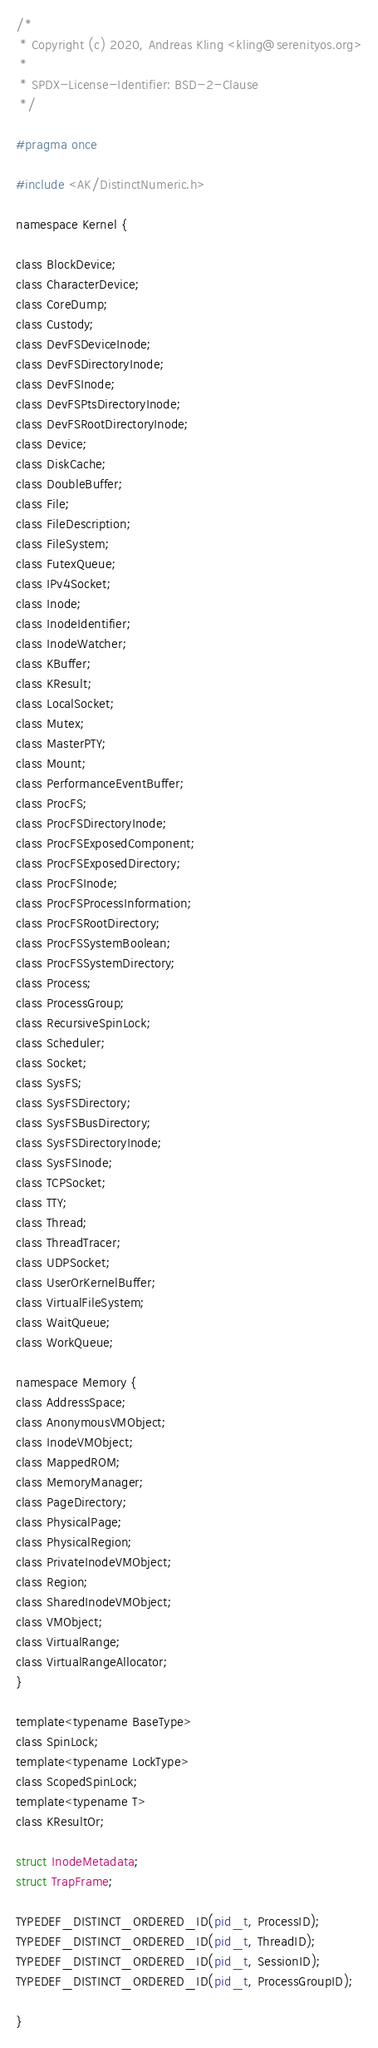Convert code to text. <code><loc_0><loc_0><loc_500><loc_500><_C_>/*
 * Copyright (c) 2020, Andreas Kling <kling@serenityos.org>
 *
 * SPDX-License-Identifier: BSD-2-Clause
 */

#pragma once

#include <AK/DistinctNumeric.h>

namespace Kernel {

class BlockDevice;
class CharacterDevice;
class CoreDump;
class Custody;
class DevFSDeviceInode;
class DevFSDirectoryInode;
class DevFSInode;
class DevFSPtsDirectoryInode;
class DevFSRootDirectoryInode;
class Device;
class DiskCache;
class DoubleBuffer;
class File;
class FileDescription;
class FileSystem;
class FutexQueue;
class IPv4Socket;
class Inode;
class InodeIdentifier;
class InodeWatcher;
class KBuffer;
class KResult;
class LocalSocket;
class Mutex;
class MasterPTY;
class Mount;
class PerformanceEventBuffer;
class ProcFS;
class ProcFSDirectoryInode;
class ProcFSExposedComponent;
class ProcFSExposedDirectory;
class ProcFSInode;
class ProcFSProcessInformation;
class ProcFSRootDirectory;
class ProcFSSystemBoolean;
class ProcFSSystemDirectory;
class Process;
class ProcessGroup;
class RecursiveSpinLock;
class Scheduler;
class Socket;
class SysFS;
class SysFSDirectory;
class SysFSBusDirectory;
class SysFSDirectoryInode;
class SysFSInode;
class TCPSocket;
class TTY;
class Thread;
class ThreadTracer;
class UDPSocket;
class UserOrKernelBuffer;
class VirtualFileSystem;
class WaitQueue;
class WorkQueue;

namespace Memory {
class AddressSpace;
class AnonymousVMObject;
class InodeVMObject;
class MappedROM;
class MemoryManager;
class PageDirectory;
class PhysicalPage;
class PhysicalRegion;
class PrivateInodeVMObject;
class Region;
class SharedInodeVMObject;
class VMObject;
class VirtualRange;
class VirtualRangeAllocator;
}

template<typename BaseType>
class SpinLock;
template<typename LockType>
class ScopedSpinLock;
template<typename T>
class KResultOr;

struct InodeMetadata;
struct TrapFrame;

TYPEDEF_DISTINCT_ORDERED_ID(pid_t, ProcessID);
TYPEDEF_DISTINCT_ORDERED_ID(pid_t, ThreadID);
TYPEDEF_DISTINCT_ORDERED_ID(pid_t, SessionID);
TYPEDEF_DISTINCT_ORDERED_ID(pid_t, ProcessGroupID);

}
</code> 